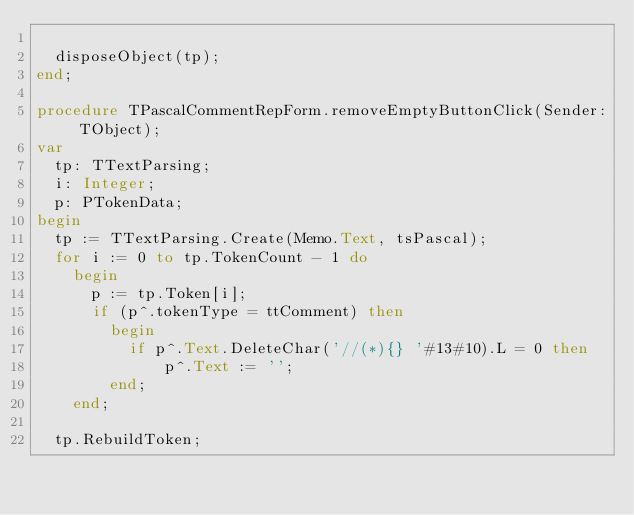Convert code to text. <code><loc_0><loc_0><loc_500><loc_500><_Pascal_>
  disposeObject(tp);
end;

procedure TPascalCommentRepForm.removeEmptyButtonClick(Sender: TObject);
var
  tp: TTextParsing;
  i: Integer;
  p: PTokenData;
begin
  tp := TTextParsing.Create(Memo.Text, tsPascal);
  for i := 0 to tp.TokenCount - 1 do
    begin
      p := tp.Token[i];
      if (p^.tokenType = ttComment) then
        begin
          if p^.Text.DeleteChar('//(*){} '#13#10).L = 0 then
              p^.Text := '';
        end;
    end;

  tp.RebuildToken;</code> 